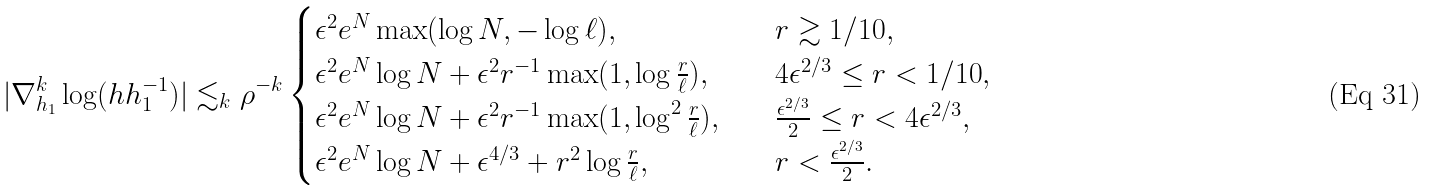<formula> <loc_0><loc_0><loc_500><loc_500>| \nabla ^ { k } _ { h _ { 1 } } \log ( h h _ { 1 } ^ { - 1 } ) | \lesssim _ { k } \rho ^ { - k } \begin{cases} \epsilon ^ { 2 } e ^ { N } \max ( \log N , - \log \ell ) , \quad & r \gtrsim 1 / 1 0 , \\ \epsilon ^ { 2 } e ^ { N } \log N + \epsilon ^ { 2 } r ^ { - 1 } \max ( 1 , \log \frac { r } { \ell } ) , \quad & 4 \epsilon ^ { 2 / 3 } \leq r < 1 / 1 0 , \\ \epsilon ^ { 2 } e ^ { N } \log N + \epsilon ^ { 2 } r ^ { - 1 } \max ( 1 , \log ^ { 2 } \frac { r } { \ell } ) , \quad & \frac { \epsilon ^ { 2 / 3 } } { 2 } \leq r < 4 \epsilon ^ { 2 / 3 } , \\ \epsilon ^ { 2 } e ^ { N } \log N + \epsilon ^ { 4 / 3 } + r ^ { 2 } \log \frac { r } { \ell } , \quad & r < \frac { \epsilon ^ { 2 / 3 } } { 2 } . \end{cases}</formula> 